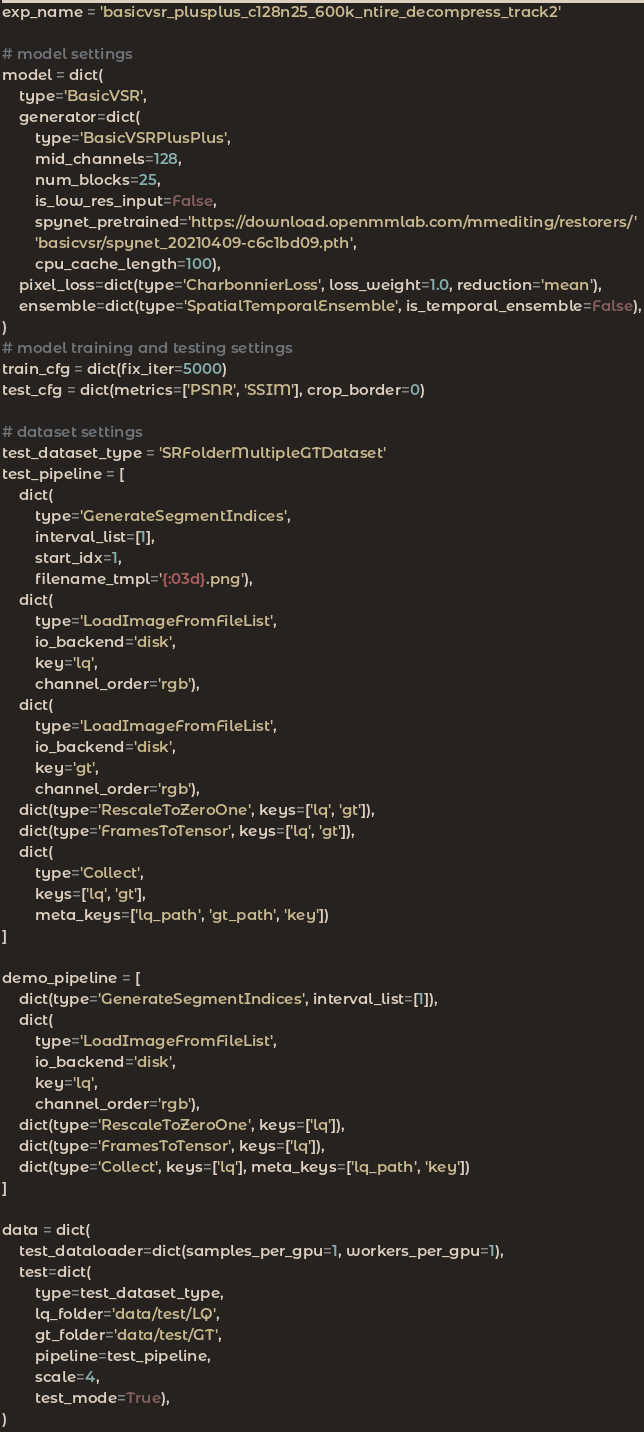<code> <loc_0><loc_0><loc_500><loc_500><_Python_>exp_name = 'basicvsr_plusplus_c128n25_600k_ntire_decompress_track2'

# model settings
model = dict(
    type='BasicVSR',
    generator=dict(
        type='BasicVSRPlusPlus',
        mid_channels=128,
        num_blocks=25,
        is_low_res_input=False,
        spynet_pretrained='https://download.openmmlab.com/mmediting/restorers/'
        'basicvsr/spynet_20210409-c6c1bd09.pth',
        cpu_cache_length=100),
    pixel_loss=dict(type='CharbonnierLoss', loss_weight=1.0, reduction='mean'),
    ensemble=dict(type='SpatialTemporalEnsemble', is_temporal_ensemble=False),
)
# model training and testing settings
train_cfg = dict(fix_iter=5000)
test_cfg = dict(metrics=['PSNR', 'SSIM'], crop_border=0)

# dataset settings
test_dataset_type = 'SRFolderMultipleGTDataset'
test_pipeline = [
    dict(
        type='GenerateSegmentIndices',
        interval_list=[1],
        start_idx=1,
        filename_tmpl='{:03d}.png'),
    dict(
        type='LoadImageFromFileList',
        io_backend='disk',
        key='lq',
        channel_order='rgb'),
    dict(
        type='LoadImageFromFileList',
        io_backend='disk',
        key='gt',
        channel_order='rgb'),
    dict(type='RescaleToZeroOne', keys=['lq', 'gt']),
    dict(type='FramesToTensor', keys=['lq', 'gt']),
    dict(
        type='Collect',
        keys=['lq', 'gt'],
        meta_keys=['lq_path', 'gt_path', 'key'])
]

demo_pipeline = [
    dict(type='GenerateSegmentIndices', interval_list=[1]),
    dict(
        type='LoadImageFromFileList',
        io_backend='disk',
        key='lq',
        channel_order='rgb'),
    dict(type='RescaleToZeroOne', keys=['lq']),
    dict(type='FramesToTensor', keys=['lq']),
    dict(type='Collect', keys=['lq'], meta_keys=['lq_path', 'key'])
]

data = dict(
    test_dataloader=dict(samples_per_gpu=1, workers_per_gpu=1),
    test=dict(
        type=test_dataset_type,
        lq_folder='data/test/LQ',
        gt_folder='data/test/GT',
        pipeline=test_pipeline,
        scale=4,
        test_mode=True),
)
</code> 